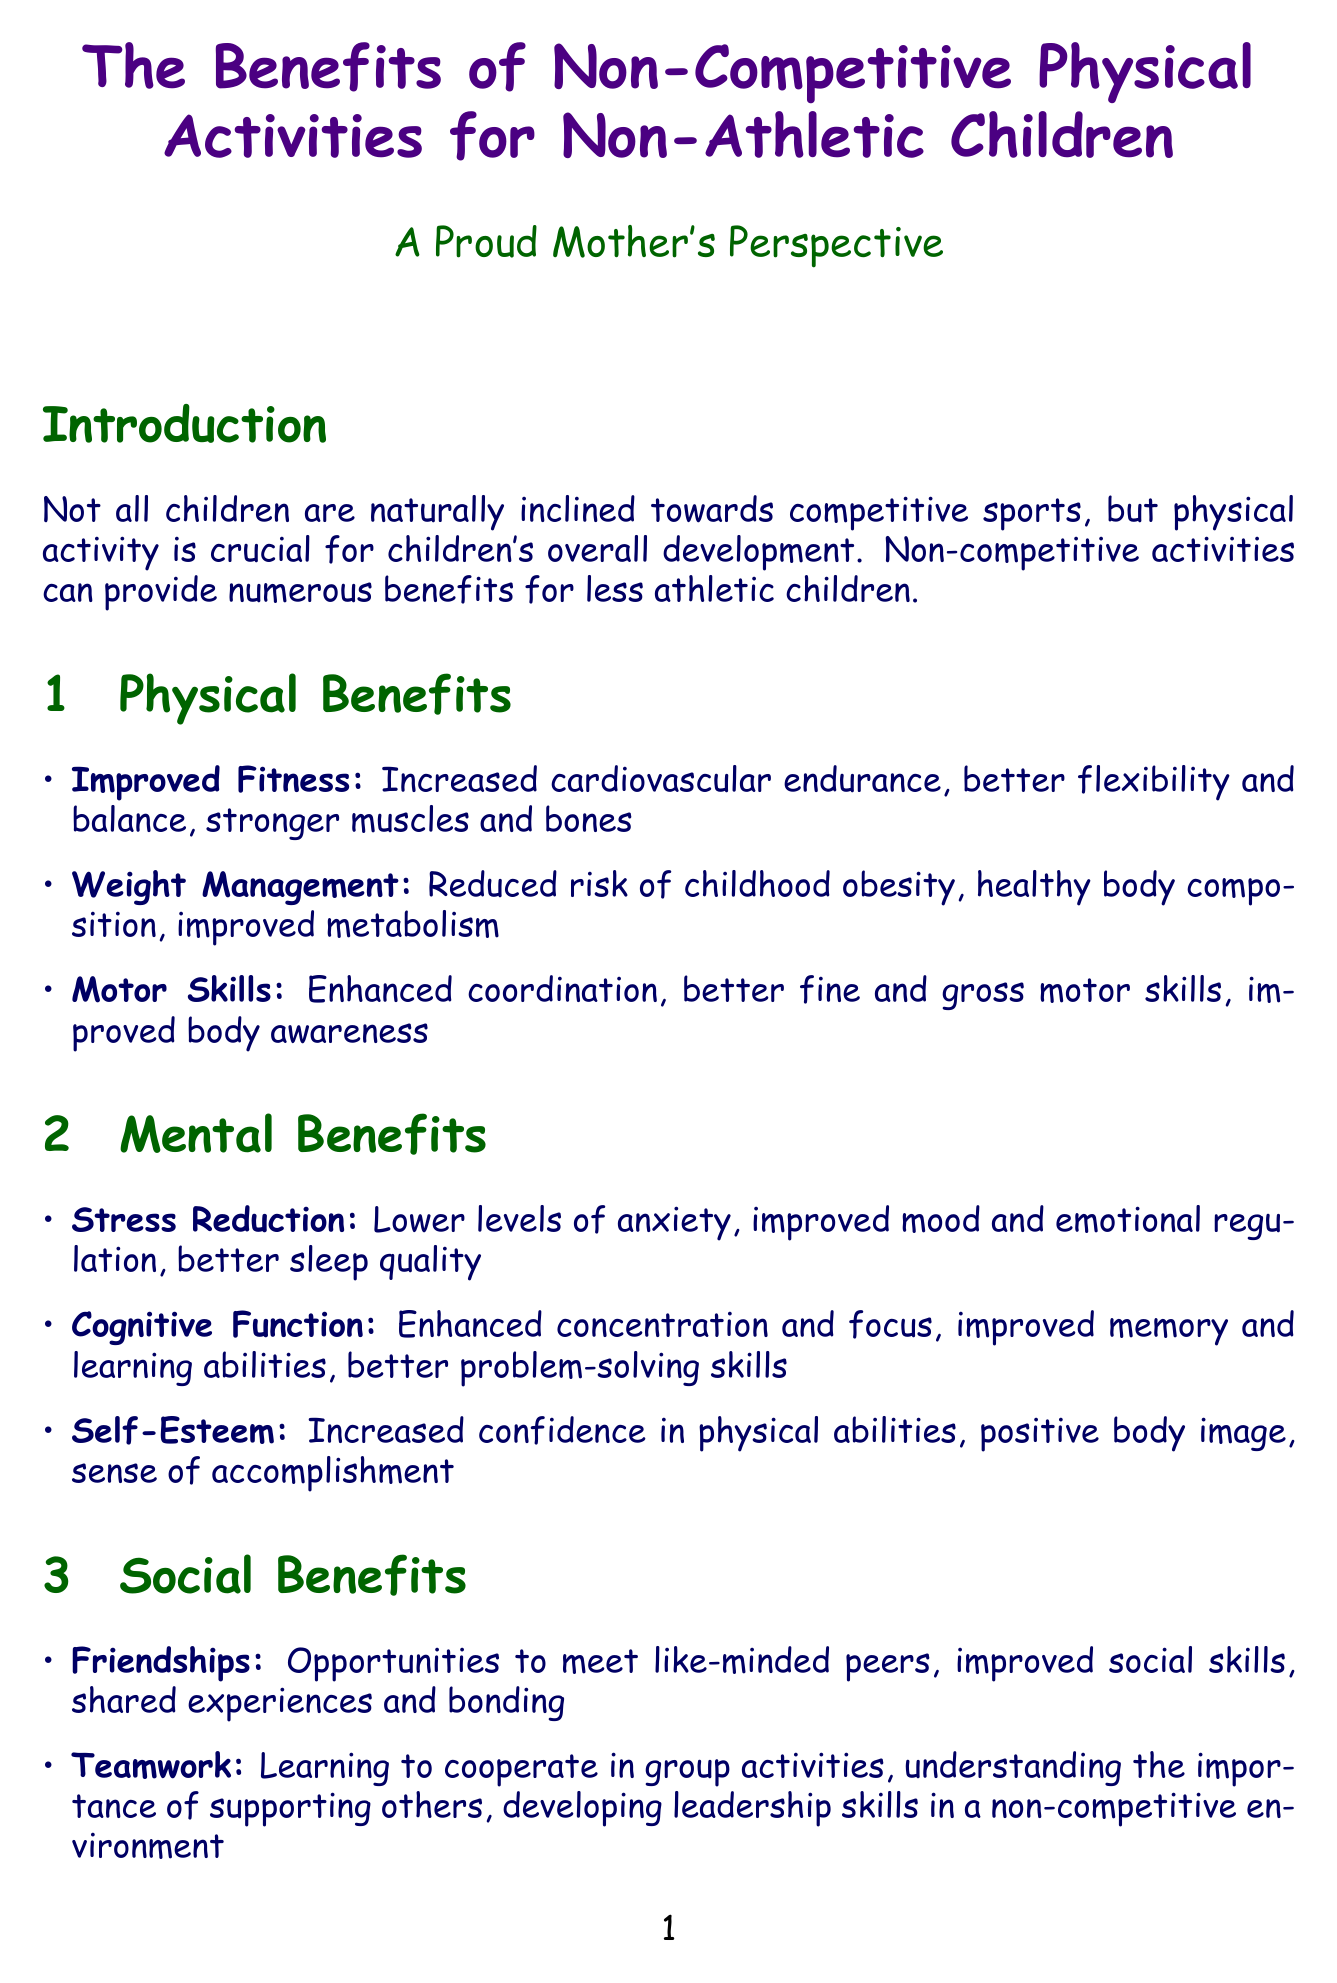What is the title of the report? The title is clearly indicated at the beginning of the document, focusing on the benefits of non-competitive physical activities for children.
Answer: The Benefits of Non-Competitive Physical Activities for Non-Athletic Children Who is the author? The author of the document is presented as a proud mother, highlighting a personal perspective on the topic.
Answer: A Proud Mother's Perspective What are two physical benefits listed? The document provides a section dedicated to physical benefits, where several specific benefits are mentioned.
Answer: Increased cardiovascular endurance, Better flexibility and balance What is one recommended activity? The report includes a list of recommended activities that provide various benefits, detailing each activity.
Answer: Yoga How many success stories are mentioned? The report highlights individual success stories, summarizing the experiences of children engaged in non-competitive activities.
Answer: Three What is one way non-competitive activities benefit self-esteem? The report discusses the impact of non-competitive activities on a child's self-esteem within the mental benefits section.
Answer: Increased confidence in physical abilities Name one expert opinion discussed in the report. The document quotes experts in the field, providing insights on the value of non-competitive activities for children's development.
Answer: "Non-competitive physical activities allow children to focus on personal growth rather than comparison with others, leading to improved self-esteem and mental well-being." What aspect does family bonding refer to? The report mentions family bonding as a key social benefit of participating in non-competitive physical activities.
Answer: Shared activities for parents and children 